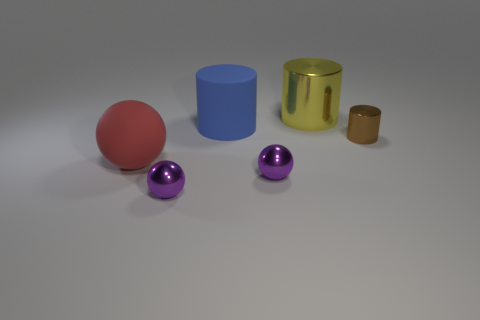Add 2 tiny cyan cylinders. How many objects exist? 8 Subtract all yellow matte balls. Subtract all large yellow metal objects. How many objects are left? 5 Add 6 purple things. How many purple things are left? 8 Add 3 shiny things. How many shiny things exist? 7 Subtract 0 yellow spheres. How many objects are left? 6 